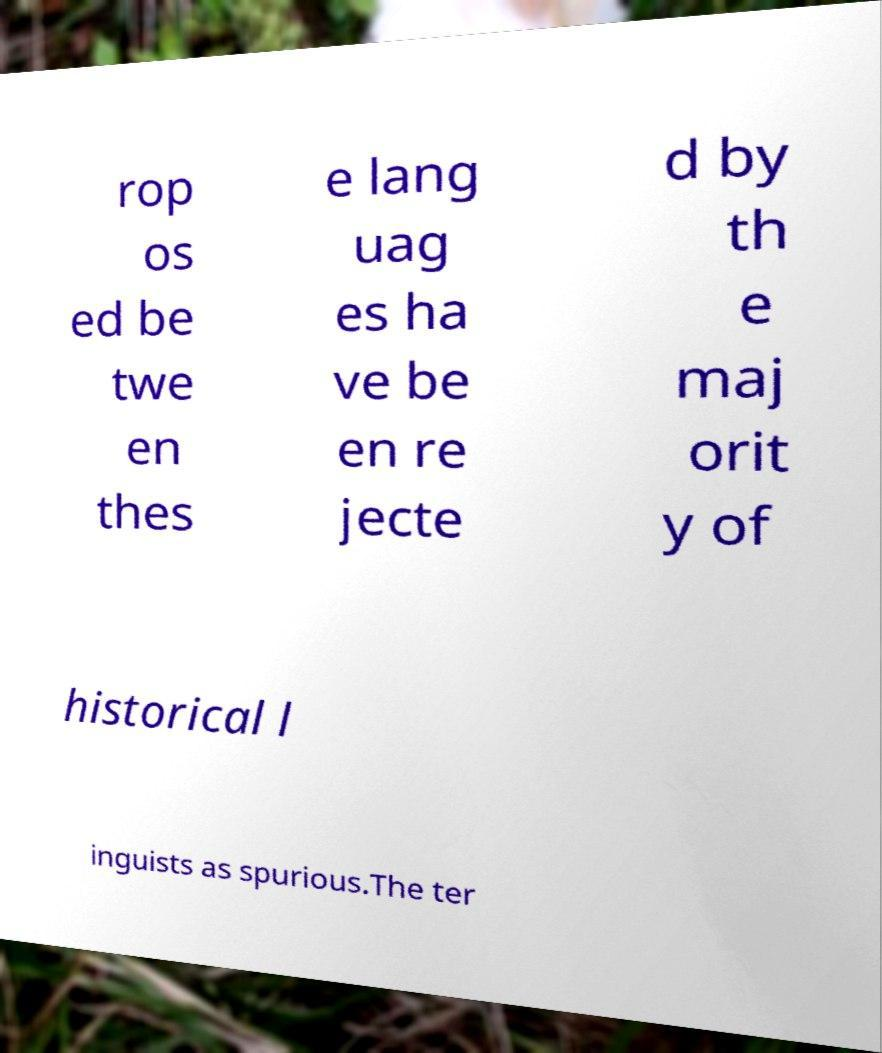For documentation purposes, I need the text within this image transcribed. Could you provide that? rop os ed be twe en thes e lang uag es ha ve be en re jecte d by th e maj orit y of historical l inguists as spurious.The ter 